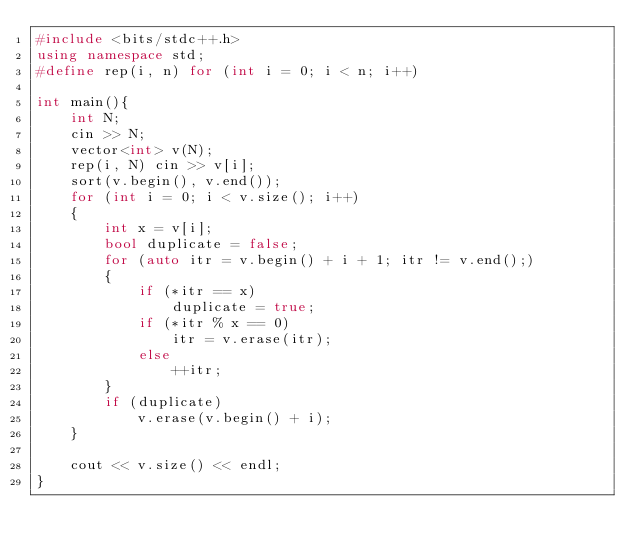<code> <loc_0><loc_0><loc_500><loc_500><_C++_>#include <bits/stdc++.h>
using namespace std;
#define rep(i, n) for (int i = 0; i < n; i++)

int main(){
    int N;
    cin >> N;
    vector<int> v(N);
    rep(i, N) cin >> v[i];
    sort(v.begin(), v.end());
    for (int i = 0; i < v.size(); i++)
    {
        int x = v[i];
        bool duplicate = false;
        for (auto itr = v.begin() + i + 1; itr != v.end();)
        {
            if (*itr == x)
                duplicate = true;
            if (*itr % x == 0)
                itr = v.erase(itr);
            else
                ++itr;
        }
        if (duplicate)
            v.erase(v.begin() + i);
    }

    cout << v.size() << endl;
}</code> 